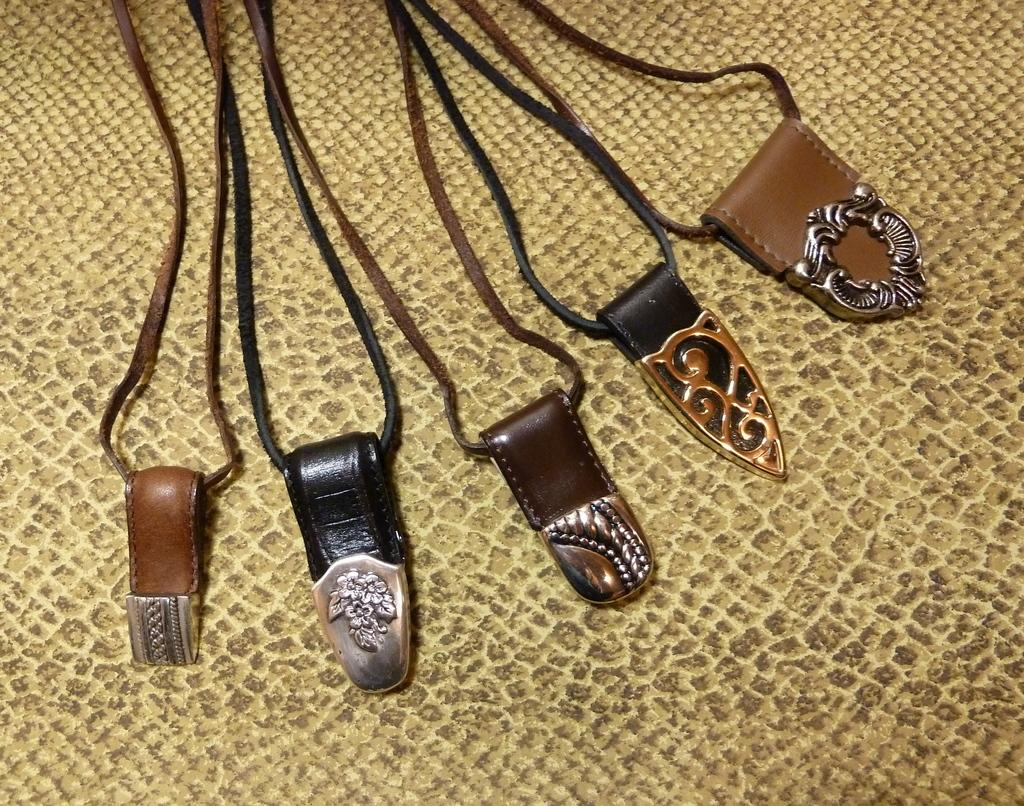What type of objects can be seen in the image? There are belts in the image. What is the color of the surface on which the belts are placed? The belts are on a yellow surface. Can you tell me how many cans are present in the image? There is no mention of cans in the provided facts, so it cannot be determined if any are present in the image. 